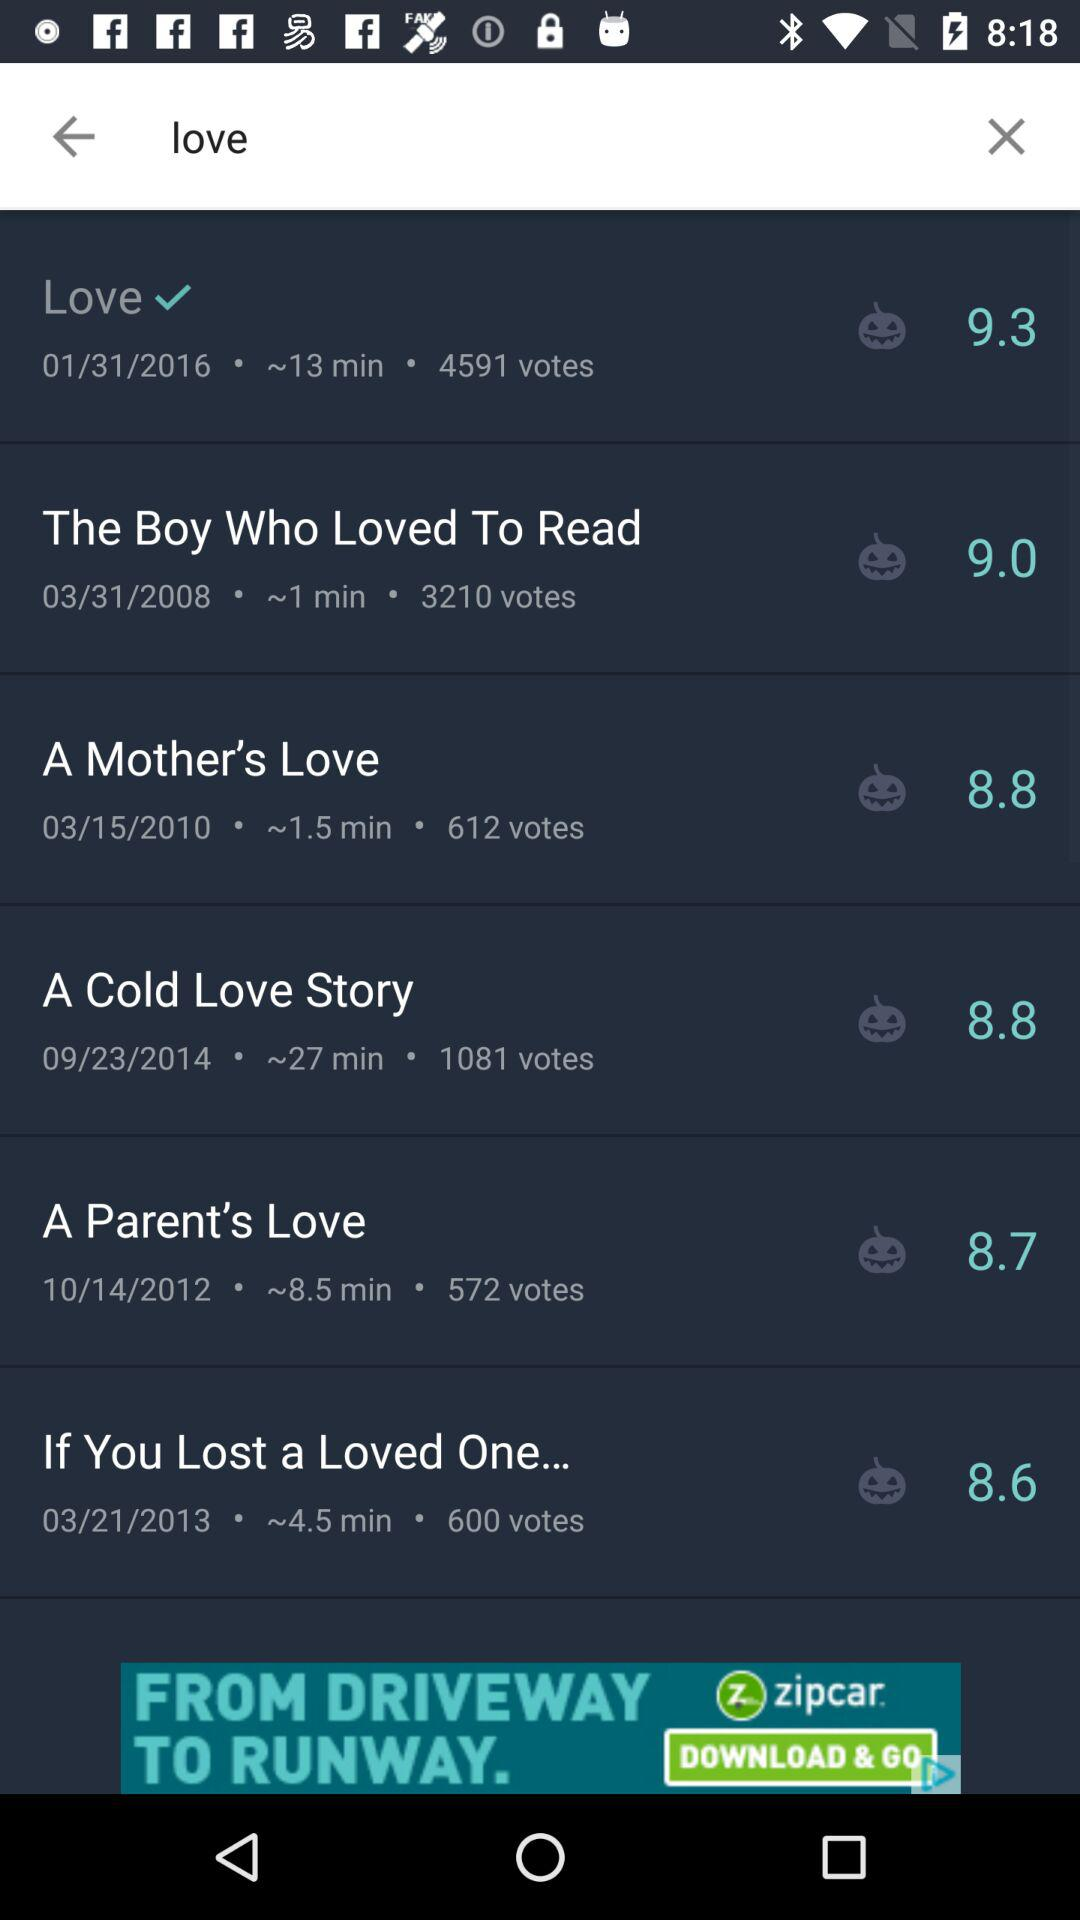What is the duration of "A Cold Love Story"? The duration is 27 minutes. 